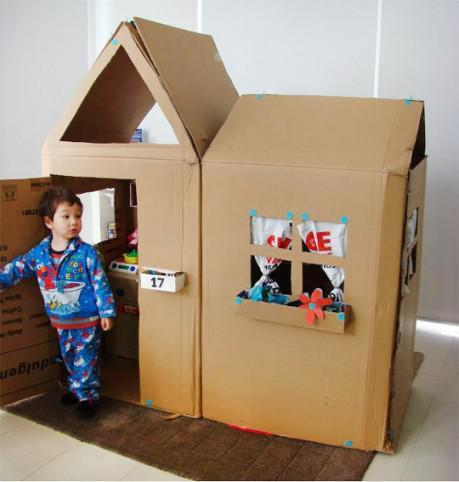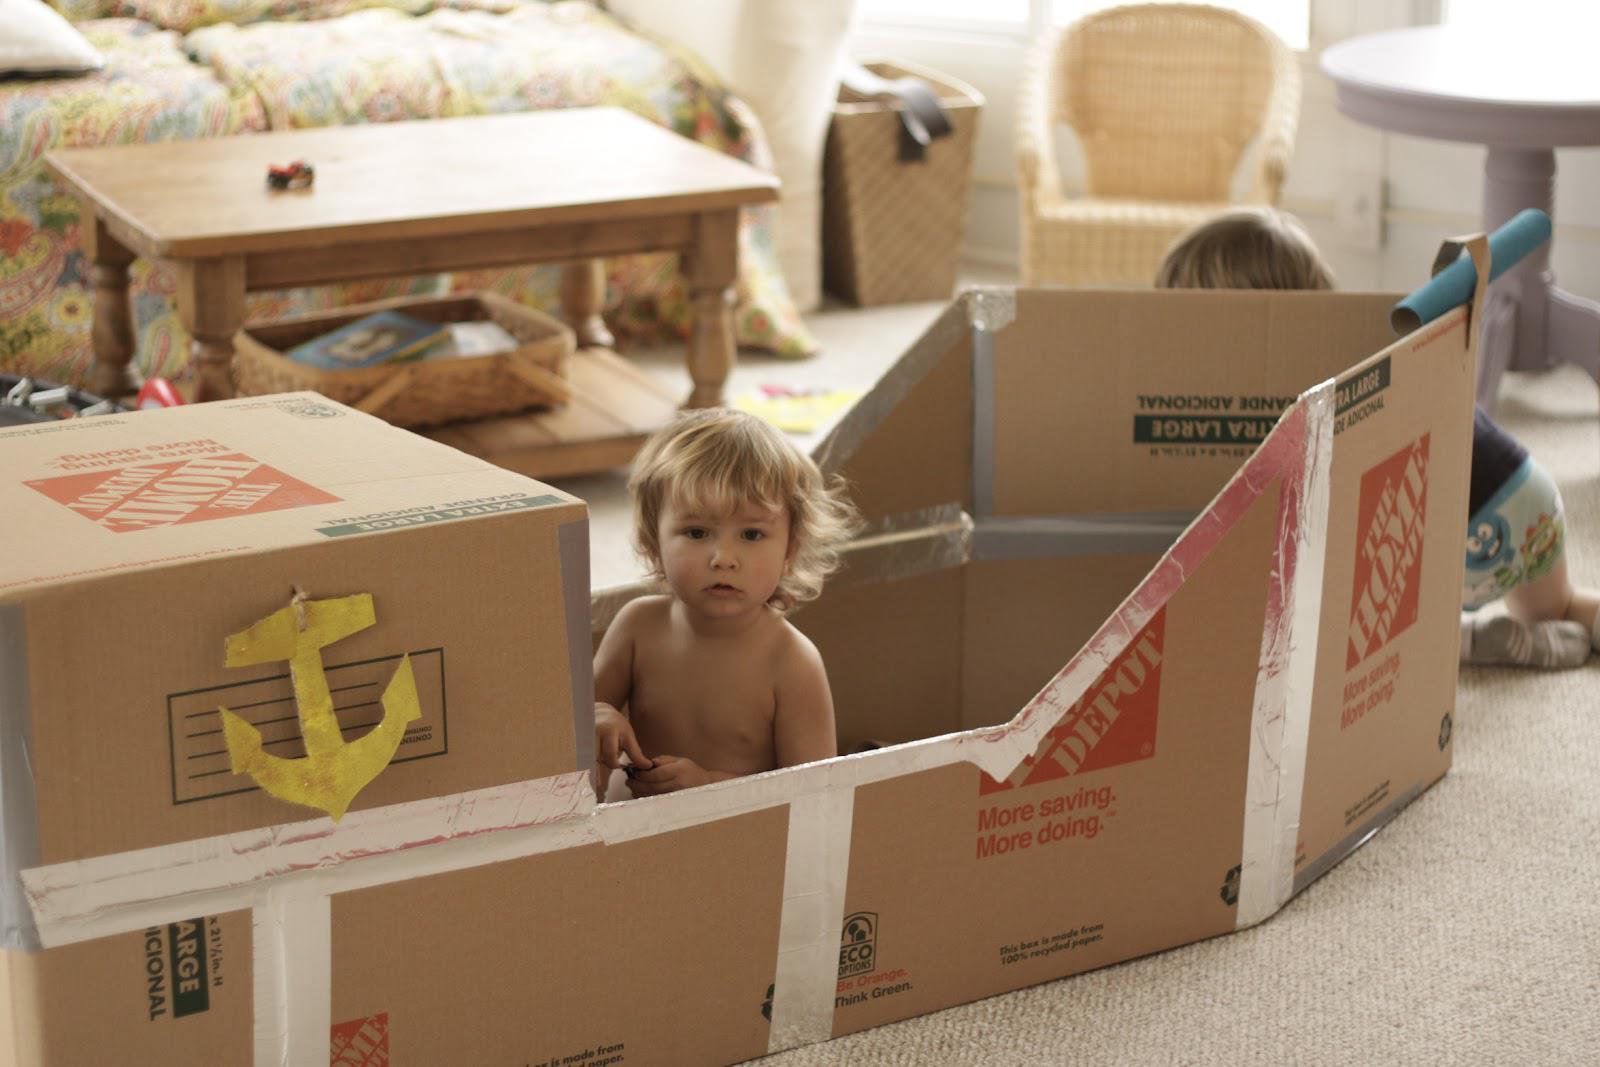The first image is the image on the left, the second image is the image on the right. For the images shown, is this caption "The right image features at least one child inside a long boat made out of joined cardboard boxes." true? Answer yes or no. Yes. The first image is the image on the left, the second image is the image on the right. Analyze the images presented: Is the assertion "One of the images shows a cardboard boat and another image shows a cardboard building." valid? Answer yes or no. Yes. 